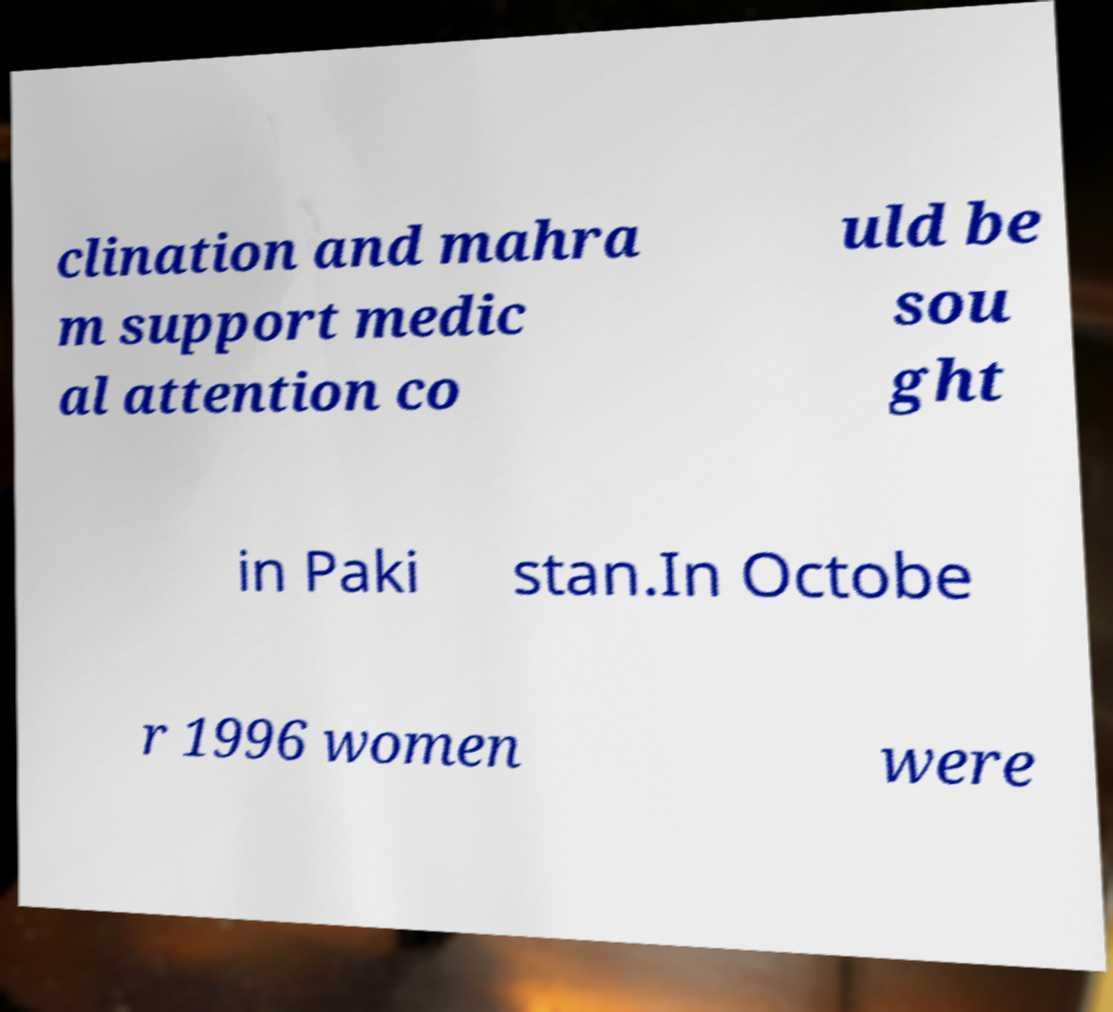Can you read and provide the text displayed in the image?This photo seems to have some interesting text. Can you extract and type it out for me? clination and mahra m support medic al attention co uld be sou ght in Paki stan.In Octobe r 1996 women were 